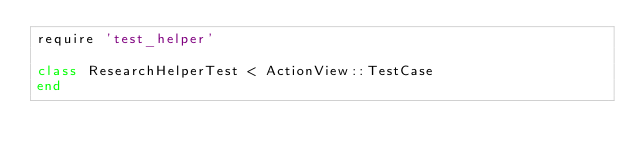<code> <loc_0><loc_0><loc_500><loc_500><_Ruby_>require 'test_helper'

class ResearchHelperTest < ActionView::TestCase
end
</code> 